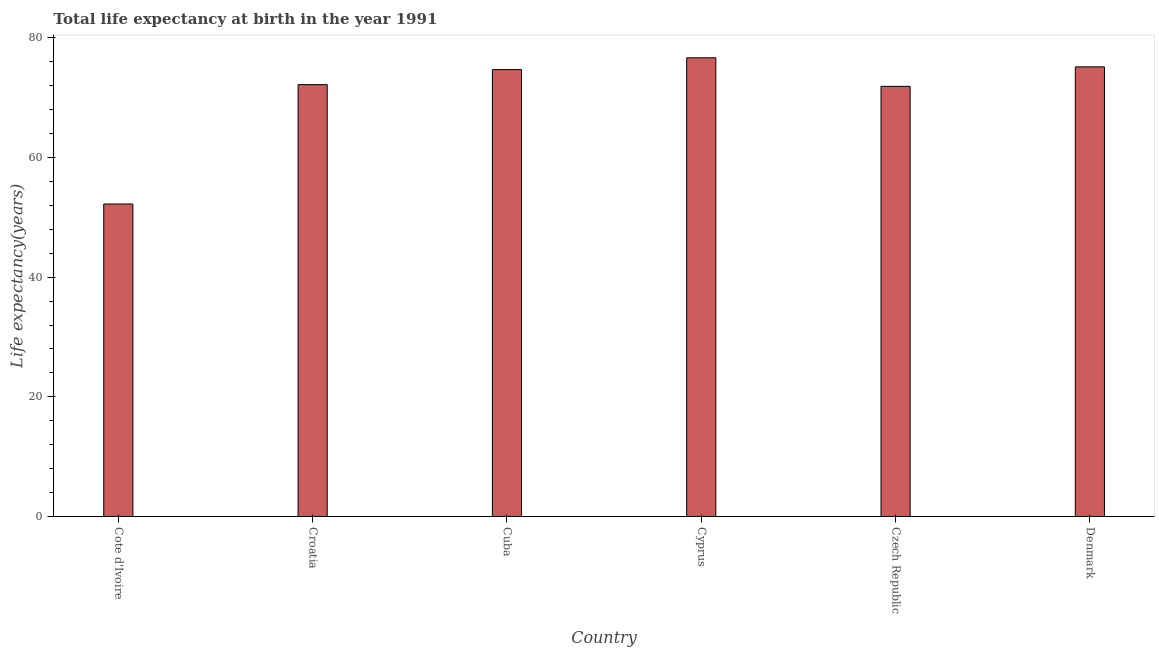What is the title of the graph?
Your response must be concise. Total life expectancy at birth in the year 1991. What is the label or title of the X-axis?
Your answer should be compact. Country. What is the label or title of the Y-axis?
Your answer should be compact. Life expectancy(years). What is the life expectancy at birth in Denmark?
Your answer should be compact. 75.16. Across all countries, what is the maximum life expectancy at birth?
Provide a short and direct response. 76.67. Across all countries, what is the minimum life expectancy at birth?
Ensure brevity in your answer.  52.23. In which country was the life expectancy at birth maximum?
Your answer should be compact. Cyprus. In which country was the life expectancy at birth minimum?
Provide a short and direct response. Cote d'Ivoire. What is the sum of the life expectancy at birth?
Offer a terse response. 422.85. What is the difference between the life expectancy at birth in Cote d'Ivoire and Cyprus?
Provide a succinct answer. -24.44. What is the average life expectancy at birth per country?
Offer a very short reply. 70.47. What is the median life expectancy at birth?
Make the answer very short. 73.44. What is the ratio of the life expectancy at birth in Cote d'Ivoire to that in Denmark?
Offer a very short reply. 0.69. What is the difference between the highest and the second highest life expectancy at birth?
Offer a terse response. 1.51. Is the sum of the life expectancy at birth in Cyprus and Czech Republic greater than the maximum life expectancy at birth across all countries?
Offer a terse response. Yes. What is the difference between the highest and the lowest life expectancy at birth?
Your answer should be very brief. 24.44. In how many countries, is the life expectancy at birth greater than the average life expectancy at birth taken over all countries?
Your answer should be compact. 5. How many bars are there?
Ensure brevity in your answer.  6. How many countries are there in the graph?
Offer a terse response. 6. Are the values on the major ticks of Y-axis written in scientific E-notation?
Give a very brief answer. No. What is the Life expectancy(years) in Cote d'Ivoire?
Provide a short and direct response. 52.23. What is the Life expectancy(years) in Croatia?
Your answer should be very brief. 72.19. What is the Life expectancy(years) of Cuba?
Offer a very short reply. 74.7. What is the Life expectancy(years) in Cyprus?
Give a very brief answer. 76.67. What is the Life expectancy(years) of Czech Republic?
Ensure brevity in your answer.  71.9. What is the Life expectancy(years) in Denmark?
Provide a short and direct response. 75.16. What is the difference between the Life expectancy(years) in Cote d'Ivoire and Croatia?
Offer a terse response. -19.95. What is the difference between the Life expectancy(years) in Cote d'Ivoire and Cuba?
Your answer should be compact. -22.47. What is the difference between the Life expectancy(years) in Cote d'Ivoire and Cyprus?
Your answer should be compact. -24.44. What is the difference between the Life expectancy(years) in Cote d'Ivoire and Czech Republic?
Make the answer very short. -19.67. What is the difference between the Life expectancy(years) in Cote d'Ivoire and Denmark?
Offer a terse response. -22.93. What is the difference between the Life expectancy(years) in Croatia and Cuba?
Your answer should be very brief. -2.52. What is the difference between the Life expectancy(years) in Croatia and Cyprus?
Your answer should be compact. -4.49. What is the difference between the Life expectancy(years) in Croatia and Czech Republic?
Your response must be concise. 0.29. What is the difference between the Life expectancy(years) in Croatia and Denmark?
Ensure brevity in your answer.  -2.97. What is the difference between the Life expectancy(years) in Cuba and Cyprus?
Give a very brief answer. -1.97. What is the difference between the Life expectancy(years) in Cuba and Czech Republic?
Give a very brief answer. 2.8. What is the difference between the Life expectancy(years) in Cuba and Denmark?
Make the answer very short. -0.46. What is the difference between the Life expectancy(years) in Cyprus and Czech Republic?
Provide a succinct answer. 4.77. What is the difference between the Life expectancy(years) in Cyprus and Denmark?
Offer a terse response. 1.51. What is the difference between the Life expectancy(years) in Czech Republic and Denmark?
Offer a terse response. -3.26. What is the ratio of the Life expectancy(years) in Cote d'Ivoire to that in Croatia?
Provide a succinct answer. 0.72. What is the ratio of the Life expectancy(years) in Cote d'Ivoire to that in Cuba?
Give a very brief answer. 0.7. What is the ratio of the Life expectancy(years) in Cote d'Ivoire to that in Cyprus?
Offer a very short reply. 0.68. What is the ratio of the Life expectancy(years) in Cote d'Ivoire to that in Czech Republic?
Your response must be concise. 0.73. What is the ratio of the Life expectancy(years) in Cote d'Ivoire to that in Denmark?
Your answer should be compact. 0.69. What is the ratio of the Life expectancy(years) in Croatia to that in Cyprus?
Provide a short and direct response. 0.94. What is the ratio of the Life expectancy(years) in Cuba to that in Czech Republic?
Your answer should be very brief. 1.04. What is the ratio of the Life expectancy(years) in Cyprus to that in Czech Republic?
Make the answer very short. 1.07. 